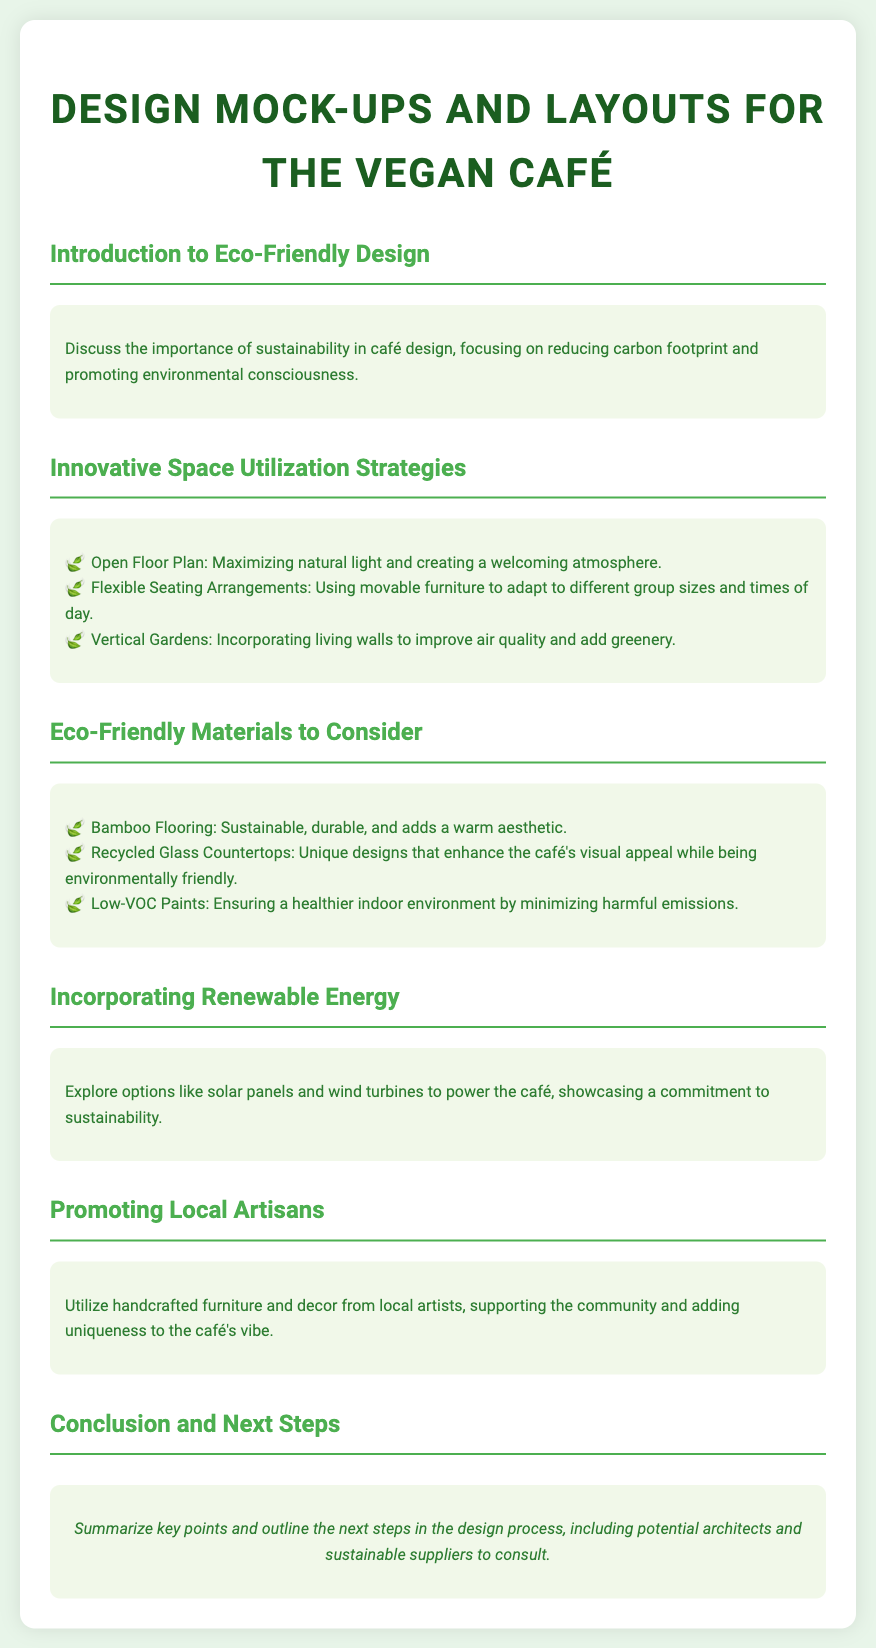What is the title of the document? The title of the document is specified in the header section of the HTML, indicating the main topic of the content.
Answer: Design Mock-ups and Layouts for the Vegan Café What color scheme is used in the document? The document mentions a green color scheme with specific shade codes visible in the CSS, reflecting the eco-friendly theme.
Answer: Green What is a benefit of open floor plans mentioned? The document lists benefits of innovative space utilization strategies, highlighting the advantages of an open floor plan.
Answer: Maximizing natural light Which material is suggested for flooring? The eco-friendly materials section specifies options that enhance sustainability in the café design.
Answer: Bamboo Flooring What can improve indoor air quality according to the document? Vertical gardens are highlighted as a feature that improves air quality and adds greenery.
Answer: Vertical Gardens What is one option for renewable energy mentioned? The document explores alternatives for energy sources that align with sustainability practices in cafés.
Answer: Solar panels What type of paint is recommended? The eco-friendly materials section indicates specific types of materials for healthier indoor environments.
Answer: Low-VOC Paints What is emphasized regarding local artisans? The document discusses the importance of collaboration with local artists in the café design context.
Answer: Supporting the community What is the conclusion about the design process? The conclusion summarizes the critical points outlined throughout the document, providing guidance on the next steps.
Answer: Next steps in the design process 